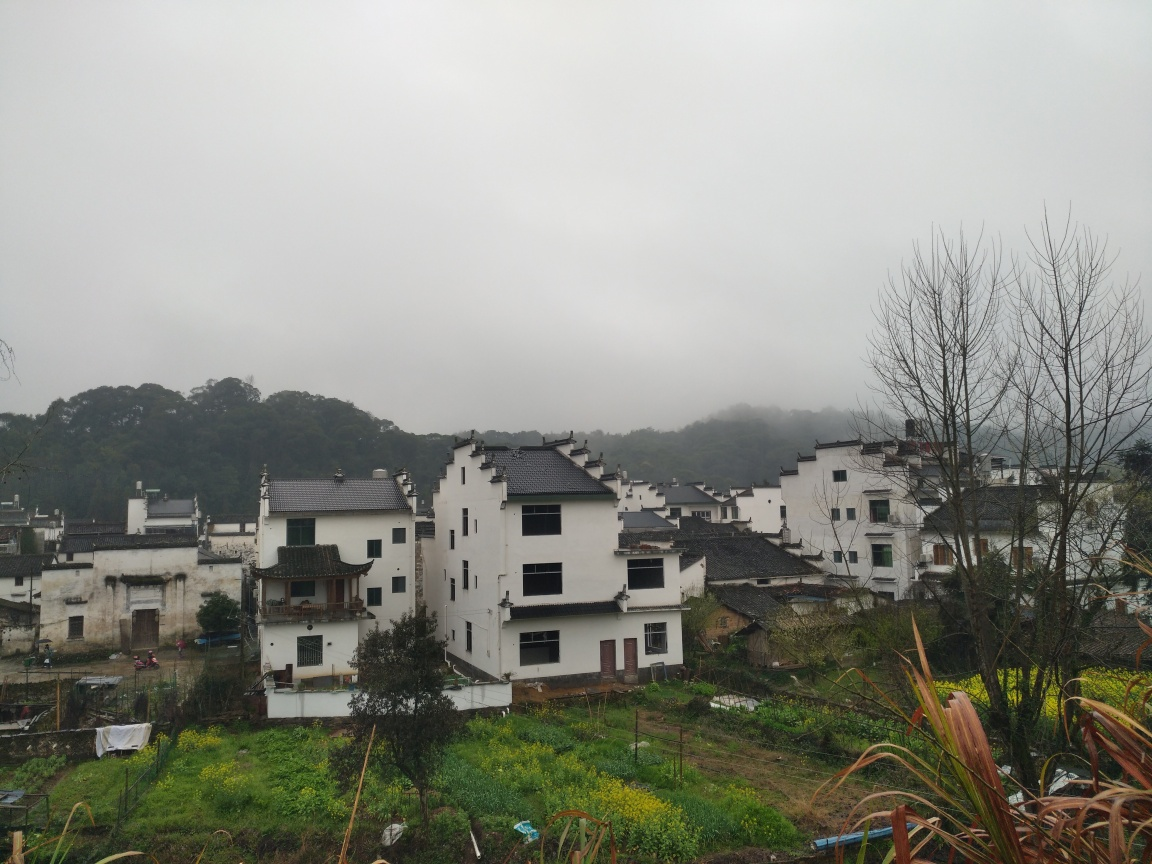Can you comment on the atmosphere this image conveys and how might the weather affect daily life in this area? This image conveys a serene yet somber atmosphere, emphasized by the grey, misty sky that hints at a damp and chilly day. The weather appears to be overcast, possibly with a light drizzle, which might make outdoor activities less appealing and could impact local farming practices. Despite this, there's a sense of tranquility and a slower pace of life, allowing residents to adapt activities around the weather patterns. 